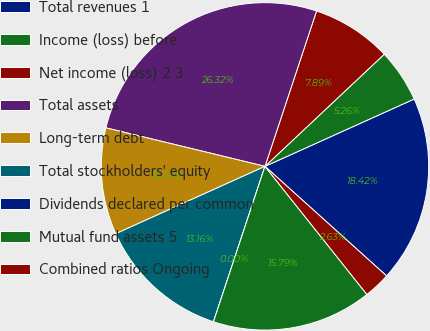Convert chart to OTSL. <chart><loc_0><loc_0><loc_500><loc_500><pie_chart><fcel>Total revenues 1<fcel>Income (loss) before<fcel>Net income (loss) 2 3<fcel>Total assets<fcel>Long-term debt<fcel>Total stockholders' equity<fcel>Dividends declared per common<fcel>Mutual fund assets 5<fcel>Combined ratios Ongoing<nl><fcel>18.42%<fcel>5.26%<fcel>7.89%<fcel>26.32%<fcel>10.53%<fcel>13.16%<fcel>0.0%<fcel>15.79%<fcel>2.63%<nl></chart> 